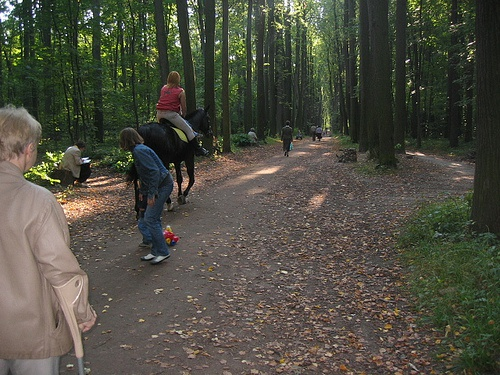Describe the objects in this image and their specific colors. I can see people in gray and darkgray tones, horse in gray, black, olive, and darkgreen tones, people in gray, black, navy, and blue tones, people in gray, maroon, and black tones, and people in gray and black tones in this image. 